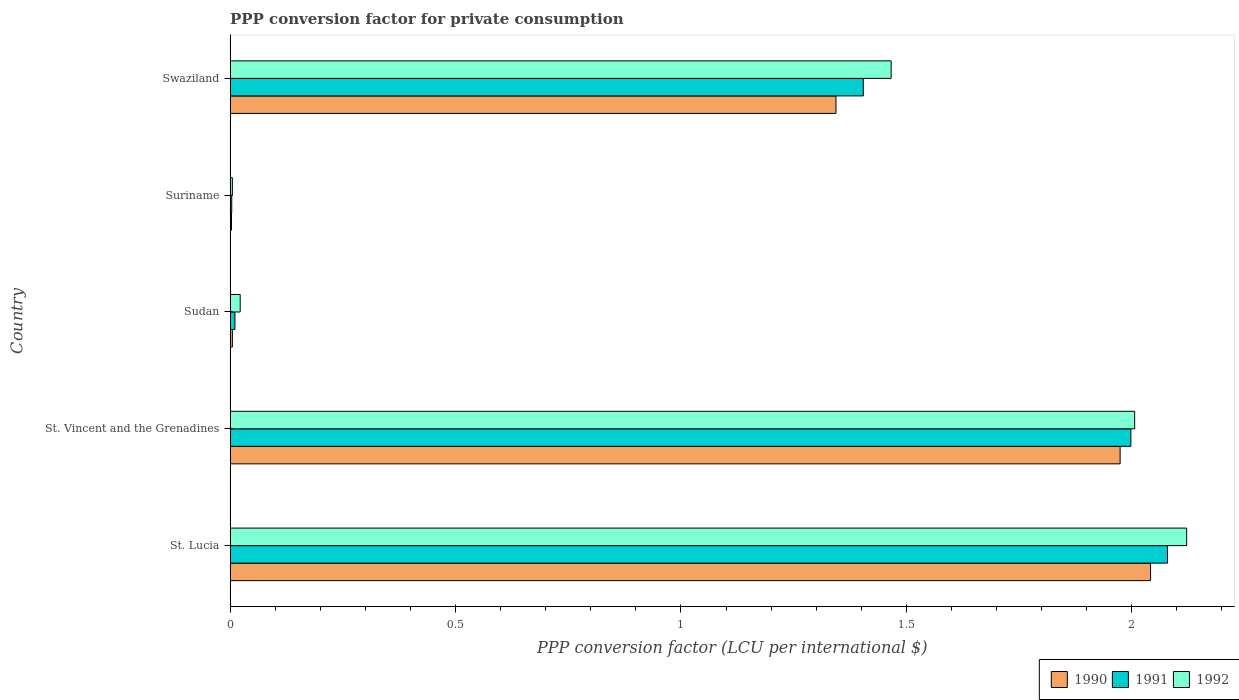How many different coloured bars are there?
Ensure brevity in your answer.  3. Are the number of bars per tick equal to the number of legend labels?
Provide a short and direct response. Yes. What is the label of the 5th group of bars from the top?
Provide a short and direct response. St. Lucia. What is the PPP conversion factor for private consumption in 1992 in Sudan?
Provide a succinct answer. 0.02. Across all countries, what is the maximum PPP conversion factor for private consumption in 1992?
Make the answer very short. 2.12. Across all countries, what is the minimum PPP conversion factor for private consumption in 1991?
Provide a succinct answer. 0. In which country was the PPP conversion factor for private consumption in 1990 maximum?
Your response must be concise. St. Lucia. In which country was the PPP conversion factor for private consumption in 1991 minimum?
Give a very brief answer. Suriname. What is the total PPP conversion factor for private consumption in 1990 in the graph?
Your answer should be very brief. 5.37. What is the difference between the PPP conversion factor for private consumption in 1991 in Suriname and that in Swaziland?
Your answer should be compact. -1.4. What is the difference between the PPP conversion factor for private consumption in 1990 in Suriname and the PPP conversion factor for private consumption in 1991 in St. Lucia?
Provide a short and direct response. -2.08. What is the average PPP conversion factor for private consumption in 1990 per country?
Provide a succinct answer. 1.07. What is the difference between the PPP conversion factor for private consumption in 1991 and PPP conversion factor for private consumption in 1990 in Suriname?
Your answer should be compact. 0. What is the ratio of the PPP conversion factor for private consumption in 1990 in St. Lucia to that in Suriname?
Ensure brevity in your answer.  710.35. Is the PPP conversion factor for private consumption in 1991 in St. Vincent and the Grenadines less than that in Swaziland?
Give a very brief answer. No. Is the difference between the PPP conversion factor for private consumption in 1991 in St. Vincent and the Grenadines and Swaziland greater than the difference between the PPP conversion factor for private consumption in 1990 in St. Vincent and the Grenadines and Swaziland?
Your answer should be very brief. No. What is the difference between the highest and the second highest PPP conversion factor for private consumption in 1990?
Your answer should be very brief. 0.07. What is the difference between the highest and the lowest PPP conversion factor for private consumption in 1991?
Your answer should be compact. 2.08. In how many countries, is the PPP conversion factor for private consumption in 1992 greater than the average PPP conversion factor for private consumption in 1992 taken over all countries?
Offer a very short reply. 3. Is the sum of the PPP conversion factor for private consumption in 1990 in St. Lucia and Sudan greater than the maximum PPP conversion factor for private consumption in 1992 across all countries?
Offer a very short reply. No. What does the 2nd bar from the top in Swaziland represents?
Your answer should be very brief. 1991. Is it the case that in every country, the sum of the PPP conversion factor for private consumption in 1991 and PPP conversion factor for private consumption in 1992 is greater than the PPP conversion factor for private consumption in 1990?
Ensure brevity in your answer.  Yes. How many bars are there?
Your response must be concise. 15. Are all the bars in the graph horizontal?
Your response must be concise. Yes. How many countries are there in the graph?
Your answer should be compact. 5. Does the graph contain any zero values?
Your answer should be very brief. No. Where does the legend appear in the graph?
Keep it short and to the point. Bottom right. What is the title of the graph?
Provide a succinct answer. PPP conversion factor for private consumption. Does "1970" appear as one of the legend labels in the graph?
Offer a terse response. No. What is the label or title of the X-axis?
Your response must be concise. PPP conversion factor (LCU per international $). What is the label or title of the Y-axis?
Keep it short and to the point. Country. What is the PPP conversion factor (LCU per international $) in 1990 in St. Lucia?
Provide a succinct answer. 2.04. What is the PPP conversion factor (LCU per international $) in 1991 in St. Lucia?
Give a very brief answer. 2.08. What is the PPP conversion factor (LCU per international $) of 1992 in St. Lucia?
Offer a very short reply. 2.12. What is the PPP conversion factor (LCU per international $) in 1990 in St. Vincent and the Grenadines?
Your response must be concise. 1.97. What is the PPP conversion factor (LCU per international $) in 1991 in St. Vincent and the Grenadines?
Your answer should be compact. 2. What is the PPP conversion factor (LCU per international $) in 1992 in St. Vincent and the Grenadines?
Offer a very short reply. 2.01. What is the PPP conversion factor (LCU per international $) in 1990 in Sudan?
Give a very brief answer. 0. What is the PPP conversion factor (LCU per international $) in 1991 in Sudan?
Ensure brevity in your answer.  0.01. What is the PPP conversion factor (LCU per international $) in 1992 in Sudan?
Offer a very short reply. 0.02. What is the PPP conversion factor (LCU per international $) in 1990 in Suriname?
Your answer should be very brief. 0. What is the PPP conversion factor (LCU per international $) in 1991 in Suriname?
Offer a terse response. 0. What is the PPP conversion factor (LCU per international $) in 1992 in Suriname?
Offer a very short reply. 0. What is the PPP conversion factor (LCU per international $) in 1990 in Swaziland?
Provide a succinct answer. 1.34. What is the PPP conversion factor (LCU per international $) in 1991 in Swaziland?
Ensure brevity in your answer.  1.4. What is the PPP conversion factor (LCU per international $) in 1992 in Swaziland?
Provide a succinct answer. 1.47. Across all countries, what is the maximum PPP conversion factor (LCU per international $) of 1990?
Your response must be concise. 2.04. Across all countries, what is the maximum PPP conversion factor (LCU per international $) of 1991?
Provide a succinct answer. 2.08. Across all countries, what is the maximum PPP conversion factor (LCU per international $) in 1992?
Your response must be concise. 2.12. Across all countries, what is the minimum PPP conversion factor (LCU per international $) in 1990?
Ensure brevity in your answer.  0. Across all countries, what is the minimum PPP conversion factor (LCU per international $) of 1991?
Make the answer very short. 0. Across all countries, what is the minimum PPP conversion factor (LCU per international $) in 1992?
Offer a very short reply. 0. What is the total PPP conversion factor (LCU per international $) of 1990 in the graph?
Your response must be concise. 5.37. What is the total PPP conversion factor (LCU per international $) in 1991 in the graph?
Your answer should be very brief. 5.5. What is the total PPP conversion factor (LCU per international $) in 1992 in the graph?
Your answer should be compact. 5.62. What is the difference between the PPP conversion factor (LCU per international $) in 1990 in St. Lucia and that in St. Vincent and the Grenadines?
Keep it short and to the point. 0.07. What is the difference between the PPP conversion factor (LCU per international $) of 1991 in St. Lucia and that in St. Vincent and the Grenadines?
Your answer should be very brief. 0.08. What is the difference between the PPP conversion factor (LCU per international $) in 1992 in St. Lucia and that in St. Vincent and the Grenadines?
Provide a succinct answer. 0.12. What is the difference between the PPP conversion factor (LCU per international $) in 1990 in St. Lucia and that in Sudan?
Your response must be concise. 2.04. What is the difference between the PPP conversion factor (LCU per international $) of 1991 in St. Lucia and that in Sudan?
Ensure brevity in your answer.  2.07. What is the difference between the PPP conversion factor (LCU per international $) in 1992 in St. Lucia and that in Sudan?
Keep it short and to the point. 2.1. What is the difference between the PPP conversion factor (LCU per international $) in 1990 in St. Lucia and that in Suriname?
Provide a succinct answer. 2.04. What is the difference between the PPP conversion factor (LCU per international $) in 1991 in St. Lucia and that in Suriname?
Offer a terse response. 2.08. What is the difference between the PPP conversion factor (LCU per international $) in 1992 in St. Lucia and that in Suriname?
Offer a very short reply. 2.12. What is the difference between the PPP conversion factor (LCU per international $) of 1990 in St. Lucia and that in Swaziland?
Provide a short and direct response. 0.7. What is the difference between the PPP conversion factor (LCU per international $) in 1991 in St. Lucia and that in Swaziland?
Your answer should be compact. 0.67. What is the difference between the PPP conversion factor (LCU per international $) of 1992 in St. Lucia and that in Swaziland?
Provide a succinct answer. 0.66. What is the difference between the PPP conversion factor (LCU per international $) of 1990 in St. Vincent and the Grenadines and that in Sudan?
Your response must be concise. 1.97. What is the difference between the PPP conversion factor (LCU per international $) of 1991 in St. Vincent and the Grenadines and that in Sudan?
Provide a short and direct response. 1.99. What is the difference between the PPP conversion factor (LCU per international $) of 1992 in St. Vincent and the Grenadines and that in Sudan?
Provide a succinct answer. 1.98. What is the difference between the PPP conversion factor (LCU per international $) of 1990 in St. Vincent and the Grenadines and that in Suriname?
Provide a short and direct response. 1.97. What is the difference between the PPP conversion factor (LCU per international $) of 1991 in St. Vincent and the Grenadines and that in Suriname?
Your answer should be very brief. 1.99. What is the difference between the PPP conversion factor (LCU per international $) in 1992 in St. Vincent and the Grenadines and that in Suriname?
Make the answer very short. 2. What is the difference between the PPP conversion factor (LCU per international $) in 1990 in St. Vincent and the Grenadines and that in Swaziland?
Ensure brevity in your answer.  0.63. What is the difference between the PPP conversion factor (LCU per international $) of 1991 in St. Vincent and the Grenadines and that in Swaziland?
Ensure brevity in your answer.  0.59. What is the difference between the PPP conversion factor (LCU per international $) of 1992 in St. Vincent and the Grenadines and that in Swaziland?
Your answer should be compact. 0.54. What is the difference between the PPP conversion factor (LCU per international $) in 1990 in Sudan and that in Suriname?
Give a very brief answer. 0. What is the difference between the PPP conversion factor (LCU per international $) of 1991 in Sudan and that in Suriname?
Your answer should be very brief. 0.01. What is the difference between the PPP conversion factor (LCU per international $) in 1992 in Sudan and that in Suriname?
Your answer should be compact. 0.02. What is the difference between the PPP conversion factor (LCU per international $) of 1990 in Sudan and that in Swaziland?
Ensure brevity in your answer.  -1.34. What is the difference between the PPP conversion factor (LCU per international $) of 1991 in Sudan and that in Swaziland?
Offer a terse response. -1.39. What is the difference between the PPP conversion factor (LCU per international $) of 1992 in Sudan and that in Swaziland?
Your answer should be compact. -1.44. What is the difference between the PPP conversion factor (LCU per international $) of 1990 in Suriname and that in Swaziland?
Give a very brief answer. -1.34. What is the difference between the PPP conversion factor (LCU per international $) in 1991 in Suriname and that in Swaziland?
Ensure brevity in your answer.  -1.4. What is the difference between the PPP conversion factor (LCU per international $) in 1992 in Suriname and that in Swaziland?
Offer a terse response. -1.46. What is the difference between the PPP conversion factor (LCU per international $) of 1990 in St. Lucia and the PPP conversion factor (LCU per international $) of 1991 in St. Vincent and the Grenadines?
Make the answer very short. 0.04. What is the difference between the PPP conversion factor (LCU per international $) in 1990 in St. Lucia and the PPP conversion factor (LCU per international $) in 1992 in St. Vincent and the Grenadines?
Provide a succinct answer. 0.04. What is the difference between the PPP conversion factor (LCU per international $) of 1991 in St. Lucia and the PPP conversion factor (LCU per international $) of 1992 in St. Vincent and the Grenadines?
Provide a succinct answer. 0.07. What is the difference between the PPP conversion factor (LCU per international $) in 1990 in St. Lucia and the PPP conversion factor (LCU per international $) in 1991 in Sudan?
Your response must be concise. 2.03. What is the difference between the PPP conversion factor (LCU per international $) in 1990 in St. Lucia and the PPP conversion factor (LCU per international $) in 1992 in Sudan?
Ensure brevity in your answer.  2.02. What is the difference between the PPP conversion factor (LCU per international $) in 1991 in St. Lucia and the PPP conversion factor (LCU per international $) in 1992 in Sudan?
Provide a short and direct response. 2.06. What is the difference between the PPP conversion factor (LCU per international $) in 1990 in St. Lucia and the PPP conversion factor (LCU per international $) in 1991 in Suriname?
Your answer should be very brief. 2.04. What is the difference between the PPP conversion factor (LCU per international $) of 1990 in St. Lucia and the PPP conversion factor (LCU per international $) of 1992 in Suriname?
Ensure brevity in your answer.  2.04. What is the difference between the PPP conversion factor (LCU per international $) in 1991 in St. Lucia and the PPP conversion factor (LCU per international $) in 1992 in Suriname?
Provide a short and direct response. 2.07. What is the difference between the PPP conversion factor (LCU per international $) in 1990 in St. Lucia and the PPP conversion factor (LCU per international $) in 1991 in Swaziland?
Make the answer very short. 0.64. What is the difference between the PPP conversion factor (LCU per international $) of 1990 in St. Lucia and the PPP conversion factor (LCU per international $) of 1992 in Swaziland?
Your answer should be compact. 0.58. What is the difference between the PPP conversion factor (LCU per international $) in 1991 in St. Lucia and the PPP conversion factor (LCU per international $) in 1992 in Swaziland?
Keep it short and to the point. 0.61. What is the difference between the PPP conversion factor (LCU per international $) of 1990 in St. Vincent and the Grenadines and the PPP conversion factor (LCU per international $) of 1991 in Sudan?
Make the answer very short. 1.96. What is the difference between the PPP conversion factor (LCU per international $) in 1990 in St. Vincent and the Grenadines and the PPP conversion factor (LCU per international $) in 1992 in Sudan?
Your answer should be compact. 1.95. What is the difference between the PPP conversion factor (LCU per international $) in 1991 in St. Vincent and the Grenadines and the PPP conversion factor (LCU per international $) in 1992 in Sudan?
Your response must be concise. 1.98. What is the difference between the PPP conversion factor (LCU per international $) of 1990 in St. Vincent and the Grenadines and the PPP conversion factor (LCU per international $) of 1991 in Suriname?
Your answer should be compact. 1.97. What is the difference between the PPP conversion factor (LCU per international $) in 1990 in St. Vincent and the Grenadines and the PPP conversion factor (LCU per international $) in 1992 in Suriname?
Offer a very short reply. 1.97. What is the difference between the PPP conversion factor (LCU per international $) of 1991 in St. Vincent and the Grenadines and the PPP conversion factor (LCU per international $) of 1992 in Suriname?
Offer a terse response. 1.99. What is the difference between the PPP conversion factor (LCU per international $) of 1990 in St. Vincent and the Grenadines and the PPP conversion factor (LCU per international $) of 1991 in Swaziland?
Offer a terse response. 0.57. What is the difference between the PPP conversion factor (LCU per international $) in 1990 in St. Vincent and the Grenadines and the PPP conversion factor (LCU per international $) in 1992 in Swaziland?
Provide a short and direct response. 0.51. What is the difference between the PPP conversion factor (LCU per international $) of 1991 in St. Vincent and the Grenadines and the PPP conversion factor (LCU per international $) of 1992 in Swaziland?
Offer a terse response. 0.53. What is the difference between the PPP conversion factor (LCU per international $) of 1990 in Sudan and the PPP conversion factor (LCU per international $) of 1991 in Suriname?
Provide a short and direct response. 0. What is the difference between the PPP conversion factor (LCU per international $) in 1990 in Sudan and the PPP conversion factor (LCU per international $) in 1992 in Suriname?
Your response must be concise. 0. What is the difference between the PPP conversion factor (LCU per international $) of 1991 in Sudan and the PPP conversion factor (LCU per international $) of 1992 in Suriname?
Offer a terse response. 0.01. What is the difference between the PPP conversion factor (LCU per international $) in 1990 in Sudan and the PPP conversion factor (LCU per international $) in 1991 in Swaziland?
Your response must be concise. -1.4. What is the difference between the PPP conversion factor (LCU per international $) of 1990 in Sudan and the PPP conversion factor (LCU per international $) of 1992 in Swaziland?
Provide a short and direct response. -1.46. What is the difference between the PPP conversion factor (LCU per international $) in 1991 in Sudan and the PPP conversion factor (LCU per international $) in 1992 in Swaziland?
Provide a succinct answer. -1.46. What is the difference between the PPP conversion factor (LCU per international $) in 1990 in Suriname and the PPP conversion factor (LCU per international $) in 1991 in Swaziland?
Provide a succinct answer. -1.4. What is the difference between the PPP conversion factor (LCU per international $) of 1990 in Suriname and the PPP conversion factor (LCU per international $) of 1992 in Swaziland?
Give a very brief answer. -1.46. What is the difference between the PPP conversion factor (LCU per international $) of 1991 in Suriname and the PPP conversion factor (LCU per international $) of 1992 in Swaziland?
Make the answer very short. -1.46. What is the average PPP conversion factor (LCU per international $) of 1990 per country?
Offer a terse response. 1.07. What is the average PPP conversion factor (LCU per international $) of 1991 per country?
Make the answer very short. 1.1. What is the average PPP conversion factor (LCU per international $) of 1992 per country?
Provide a short and direct response. 1.12. What is the difference between the PPP conversion factor (LCU per international $) in 1990 and PPP conversion factor (LCU per international $) in 1991 in St. Lucia?
Offer a terse response. -0.04. What is the difference between the PPP conversion factor (LCU per international $) in 1990 and PPP conversion factor (LCU per international $) in 1992 in St. Lucia?
Ensure brevity in your answer.  -0.08. What is the difference between the PPP conversion factor (LCU per international $) in 1991 and PPP conversion factor (LCU per international $) in 1992 in St. Lucia?
Provide a succinct answer. -0.04. What is the difference between the PPP conversion factor (LCU per international $) in 1990 and PPP conversion factor (LCU per international $) in 1991 in St. Vincent and the Grenadines?
Keep it short and to the point. -0.02. What is the difference between the PPP conversion factor (LCU per international $) of 1990 and PPP conversion factor (LCU per international $) of 1992 in St. Vincent and the Grenadines?
Provide a succinct answer. -0.03. What is the difference between the PPP conversion factor (LCU per international $) in 1991 and PPP conversion factor (LCU per international $) in 1992 in St. Vincent and the Grenadines?
Keep it short and to the point. -0.01. What is the difference between the PPP conversion factor (LCU per international $) in 1990 and PPP conversion factor (LCU per international $) in 1991 in Sudan?
Offer a terse response. -0.01. What is the difference between the PPP conversion factor (LCU per international $) of 1990 and PPP conversion factor (LCU per international $) of 1992 in Sudan?
Keep it short and to the point. -0.02. What is the difference between the PPP conversion factor (LCU per international $) in 1991 and PPP conversion factor (LCU per international $) in 1992 in Sudan?
Your answer should be compact. -0.01. What is the difference between the PPP conversion factor (LCU per international $) of 1990 and PPP conversion factor (LCU per international $) of 1991 in Suriname?
Keep it short and to the point. -0. What is the difference between the PPP conversion factor (LCU per international $) of 1990 and PPP conversion factor (LCU per international $) of 1992 in Suriname?
Offer a very short reply. -0. What is the difference between the PPP conversion factor (LCU per international $) in 1991 and PPP conversion factor (LCU per international $) in 1992 in Suriname?
Provide a succinct answer. -0. What is the difference between the PPP conversion factor (LCU per international $) in 1990 and PPP conversion factor (LCU per international $) in 1991 in Swaziland?
Give a very brief answer. -0.06. What is the difference between the PPP conversion factor (LCU per international $) in 1990 and PPP conversion factor (LCU per international $) in 1992 in Swaziland?
Give a very brief answer. -0.12. What is the difference between the PPP conversion factor (LCU per international $) of 1991 and PPP conversion factor (LCU per international $) of 1992 in Swaziland?
Give a very brief answer. -0.06. What is the ratio of the PPP conversion factor (LCU per international $) of 1990 in St. Lucia to that in St. Vincent and the Grenadines?
Your answer should be very brief. 1.03. What is the ratio of the PPP conversion factor (LCU per international $) of 1991 in St. Lucia to that in St. Vincent and the Grenadines?
Offer a very short reply. 1.04. What is the ratio of the PPP conversion factor (LCU per international $) of 1992 in St. Lucia to that in St. Vincent and the Grenadines?
Give a very brief answer. 1.06. What is the ratio of the PPP conversion factor (LCU per international $) in 1990 in St. Lucia to that in Sudan?
Ensure brevity in your answer.  416.59. What is the ratio of the PPP conversion factor (LCU per international $) in 1991 in St. Lucia to that in Sudan?
Provide a succinct answer. 197.79. What is the ratio of the PPP conversion factor (LCU per international $) in 1992 in St. Lucia to that in Sudan?
Keep it short and to the point. 95.55. What is the ratio of the PPP conversion factor (LCU per international $) in 1990 in St. Lucia to that in Suriname?
Make the answer very short. 710.35. What is the ratio of the PPP conversion factor (LCU per international $) in 1991 in St. Lucia to that in Suriname?
Your answer should be very brief. 598.59. What is the ratio of the PPP conversion factor (LCU per international $) in 1992 in St. Lucia to that in Suriname?
Offer a very short reply. 438.06. What is the ratio of the PPP conversion factor (LCU per international $) in 1990 in St. Lucia to that in Swaziland?
Your answer should be compact. 1.52. What is the ratio of the PPP conversion factor (LCU per international $) of 1991 in St. Lucia to that in Swaziland?
Your response must be concise. 1.48. What is the ratio of the PPP conversion factor (LCU per international $) of 1992 in St. Lucia to that in Swaziland?
Make the answer very short. 1.45. What is the ratio of the PPP conversion factor (LCU per international $) of 1990 in St. Vincent and the Grenadines to that in Sudan?
Your answer should be very brief. 402.81. What is the ratio of the PPP conversion factor (LCU per international $) in 1991 in St. Vincent and the Grenadines to that in Sudan?
Keep it short and to the point. 190.06. What is the ratio of the PPP conversion factor (LCU per international $) of 1992 in St. Vincent and the Grenadines to that in Sudan?
Give a very brief answer. 90.36. What is the ratio of the PPP conversion factor (LCU per international $) in 1990 in St. Vincent and the Grenadines to that in Suriname?
Make the answer very short. 686.85. What is the ratio of the PPP conversion factor (LCU per international $) of 1991 in St. Vincent and the Grenadines to that in Suriname?
Offer a terse response. 575.21. What is the ratio of the PPP conversion factor (LCU per international $) in 1992 in St. Vincent and the Grenadines to that in Suriname?
Offer a terse response. 414.24. What is the ratio of the PPP conversion factor (LCU per international $) in 1990 in St. Vincent and the Grenadines to that in Swaziland?
Give a very brief answer. 1.47. What is the ratio of the PPP conversion factor (LCU per international $) in 1991 in St. Vincent and the Grenadines to that in Swaziland?
Your response must be concise. 1.42. What is the ratio of the PPP conversion factor (LCU per international $) of 1992 in St. Vincent and the Grenadines to that in Swaziland?
Offer a very short reply. 1.37. What is the ratio of the PPP conversion factor (LCU per international $) in 1990 in Sudan to that in Suriname?
Offer a terse response. 1.71. What is the ratio of the PPP conversion factor (LCU per international $) of 1991 in Sudan to that in Suriname?
Your answer should be very brief. 3.03. What is the ratio of the PPP conversion factor (LCU per international $) of 1992 in Sudan to that in Suriname?
Make the answer very short. 4.58. What is the ratio of the PPP conversion factor (LCU per international $) of 1990 in Sudan to that in Swaziland?
Keep it short and to the point. 0. What is the ratio of the PPP conversion factor (LCU per international $) of 1991 in Sudan to that in Swaziland?
Your response must be concise. 0.01. What is the ratio of the PPP conversion factor (LCU per international $) in 1992 in Sudan to that in Swaziland?
Give a very brief answer. 0.02. What is the ratio of the PPP conversion factor (LCU per international $) in 1990 in Suriname to that in Swaziland?
Provide a short and direct response. 0. What is the ratio of the PPP conversion factor (LCU per international $) of 1991 in Suriname to that in Swaziland?
Your answer should be compact. 0. What is the ratio of the PPP conversion factor (LCU per international $) of 1992 in Suriname to that in Swaziland?
Provide a succinct answer. 0. What is the difference between the highest and the second highest PPP conversion factor (LCU per international $) of 1990?
Provide a succinct answer. 0.07. What is the difference between the highest and the second highest PPP conversion factor (LCU per international $) in 1991?
Provide a short and direct response. 0.08. What is the difference between the highest and the second highest PPP conversion factor (LCU per international $) of 1992?
Give a very brief answer. 0.12. What is the difference between the highest and the lowest PPP conversion factor (LCU per international $) of 1990?
Provide a succinct answer. 2.04. What is the difference between the highest and the lowest PPP conversion factor (LCU per international $) in 1991?
Your answer should be compact. 2.08. What is the difference between the highest and the lowest PPP conversion factor (LCU per international $) of 1992?
Your answer should be very brief. 2.12. 